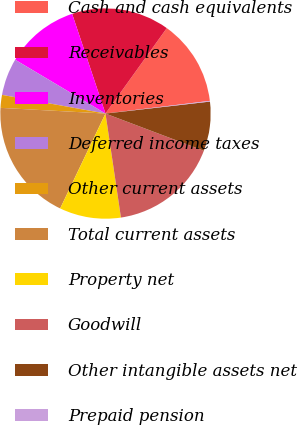<chart> <loc_0><loc_0><loc_500><loc_500><pie_chart><fcel>Cash and cash equivalents<fcel>Receivables<fcel>Inventories<fcel>Deferred income taxes<fcel>Other current assets<fcel>Total current assets<fcel>Property net<fcel>Goodwill<fcel>Other intangible assets net<fcel>Prepaid pension<nl><fcel>13.17%<fcel>15.04%<fcel>11.31%<fcel>5.71%<fcel>1.98%<fcel>18.77%<fcel>9.44%<fcel>16.9%<fcel>7.57%<fcel>0.11%<nl></chart> 